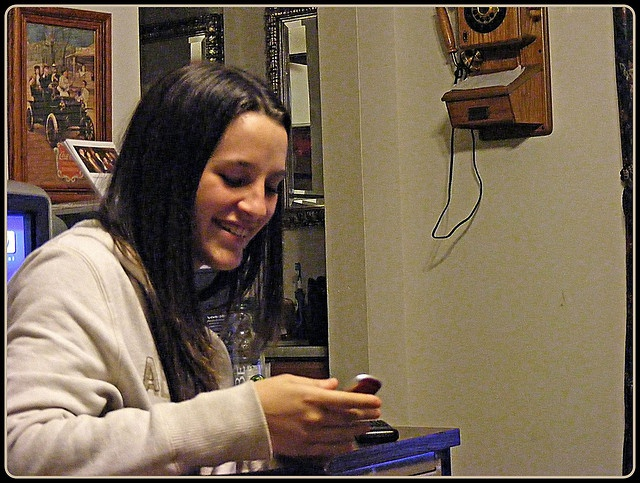Describe the objects in this image and their specific colors. I can see people in black, lightgray, tan, and maroon tones, tv in black, navy, lightblue, and blue tones, cell phone in black, gray, and tan tones, cell phone in black, maroon, gray, and white tones, and toothbrush in black and gray tones in this image. 